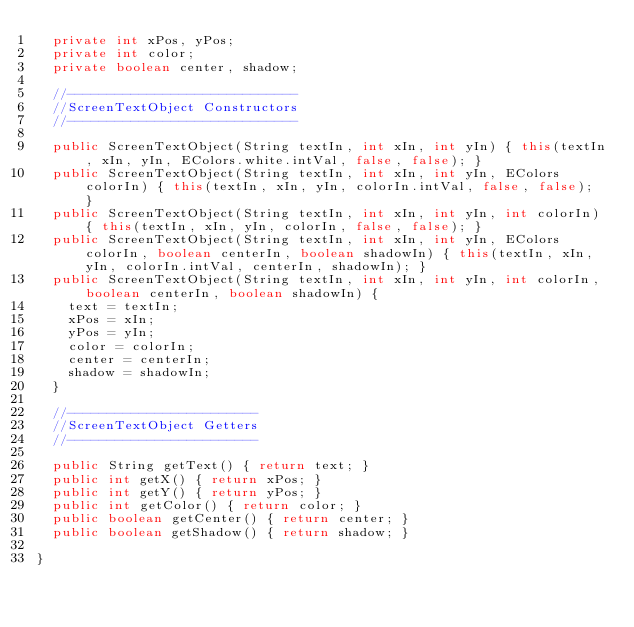<code> <loc_0><loc_0><loc_500><loc_500><_Java_>	private int xPos, yPos;
	private int color;
	private boolean center, shadow;
	
	//-----------------------------
	//ScreenTextObject Constructors
	//-----------------------------
	
	public ScreenTextObject(String textIn, int xIn, int yIn) { this(textIn, xIn, yIn, EColors.white.intVal, false, false); }
	public ScreenTextObject(String textIn, int xIn, int yIn, EColors colorIn) { this(textIn, xIn, yIn, colorIn.intVal, false, false); }
	public ScreenTextObject(String textIn, int xIn, int yIn, int colorIn) { this(textIn, xIn, yIn, colorIn, false, false); }
	public ScreenTextObject(String textIn, int xIn, int yIn, EColors colorIn, boolean centerIn, boolean shadowIn) { this(textIn, xIn, yIn, colorIn.intVal, centerIn, shadowIn); }
	public ScreenTextObject(String textIn, int xIn, int yIn, int colorIn, boolean centerIn, boolean shadowIn) {
		text = textIn;
		xPos = xIn;
		yPos = yIn;
		color = colorIn;
		center = centerIn;
		shadow = shadowIn;
	}
	
	//------------------------
	//ScreenTextObject Getters
	//------------------------
	
	public String getText() { return text; }
	public int getX() { return xPos; }
	public int getY() { return yPos; }
	public int getColor() { return color; }
	public boolean getCenter() { return center; }
	public boolean getShadow() { return shadow; }
	
}
</code> 